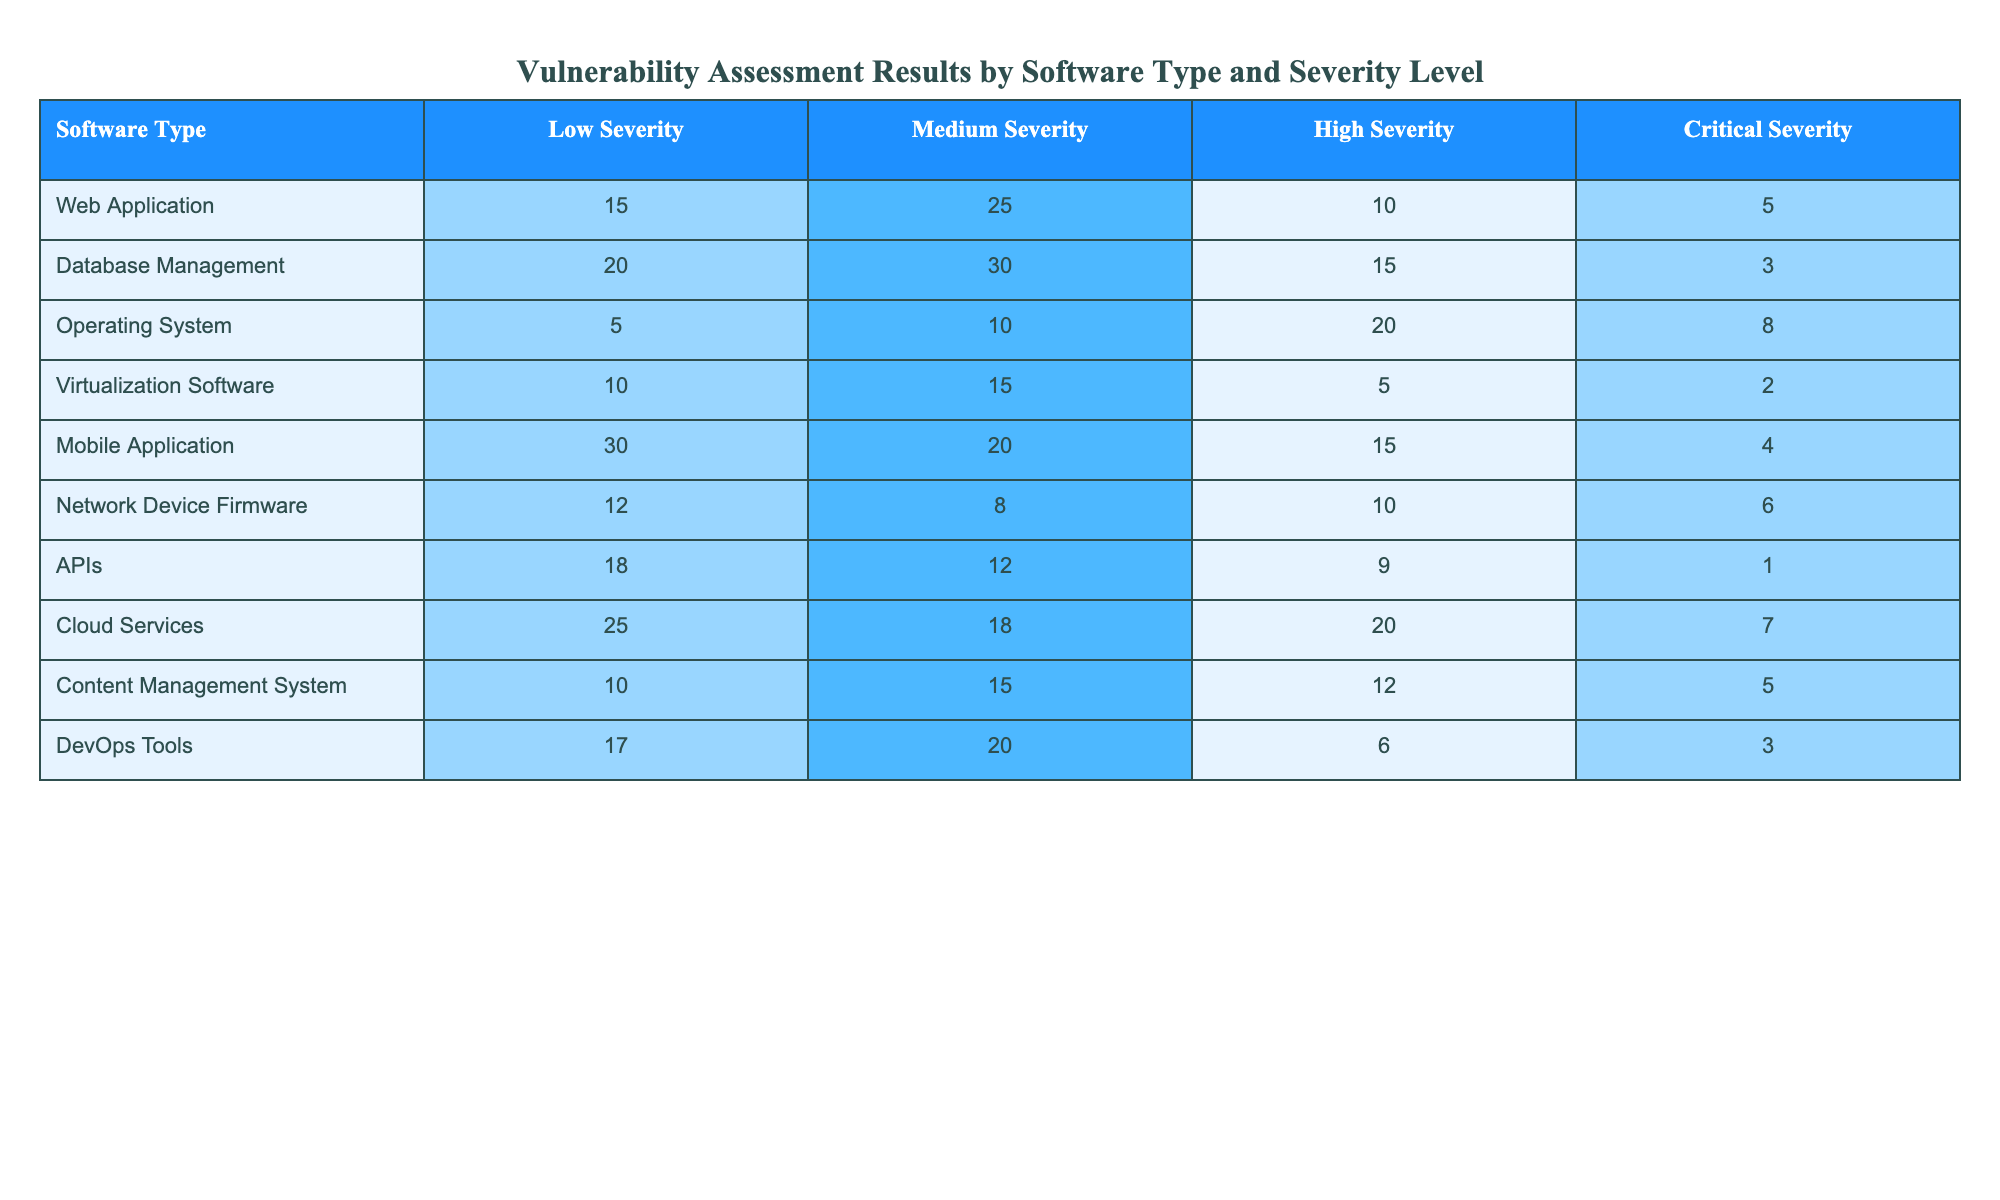What is the highest number of high severity vulnerabilities found in a single software type? The numbers of high severity vulnerabilities for each software type are as follows: Web Application (10), Database Management (15), Operating System (20), Virtualization Software (5), Mobile Application (15), Network Device Firmware (10), APIs (9), Cloud Services (20), Content Management System (12), and DevOps Tools (6). The highest number is 20 from both Operating System and Cloud Services.
Answer: 20 Which software type has the most medium severity vulnerabilities? The medium severity numbers are: Web Application (25), Database Management (30), Operating System (10), Virtualization Software (15), Mobile Application (20), Network Device Firmware (8), APIs (12), Cloud Services (18), Content Management System (15), and DevOps Tools (20). The highest is 30 for Database Management.
Answer: Database Management What is the total number of critical vulnerabilities across all software types? The critical severity counts are: Web Application (5), Database Management (3), Operating System (8), Virtualization Software (2), Mobile Application (4), Network Device Firmware (6), APIs (1), Cloud Services (7), Content Management System (5), and DevOps Tools (3). Adding these gives 5 + 3 + 8 + 2 + 4 + 6 + 1 + 7 + 5 + 3 = 44.
Answer: 44 Is the number of low severity vulnerabilities in Mobile Applications greater than in Web Applications? The low severity counts are: Mobile Application (30) and Web Application (15). Since 30 is greater than 15, the answer is yes.
Answer: Yes What is the average number of high severity vulnerabilities across all software types? The high severity counts are: Web Application (10), Database Management (15), Operating System (20), Virtualization Software (5), Mobile Application (15), Network Device Firmware (10), APIs (9), Cloud Services (20), Content Management System (12), and DevOps Tools (6). Summing these gives 10 + 15 + 20 + 5 + 15 + 10 + 9 + 20 + 12 + 6 = 132. There are 10 software types, so the average is 132 / 10 = 13.2.
Answer: 13.2 Which software type has the least number of critical vulnerabilities? The counts of critical vulnerabilities are: Web Application (5), Database Management (3), Operating System (8), Virtualization Software (2), Mobile Application (4), Network Device Firmware (6), APIs (1), Cloud Services (7), Content Management System (5), and DevOps Tools (3). The lowest is 1 for APIs.
Answer: APIs Do Cloud Services have more total vulnerabilities than Virtualization Software? To compare, we need to sum all types of vulnerabilities for both. Cloud Services: Low (25) + Medium (18) + High (20) + Critical (7) = 70. Virtualization Software: Low (10) + Medium (15) + High (5) + Critical (2) = 32. Since 70 is greater than 32, the answer is yes.
Answer: Yes How many software types have a total of more than 20 vulnerabilities? We total each software type: Web Application (55), Database Management (68), Operating System (53), Virtualization Software (32), Mobile Application (69), Network Device Firmware (46), APIs (40), Cloud Services (70), Content Management System (42), DevOps Tools (46). The software types with totals above 20 are all of them. There are 10 software types.
Answer: 10 